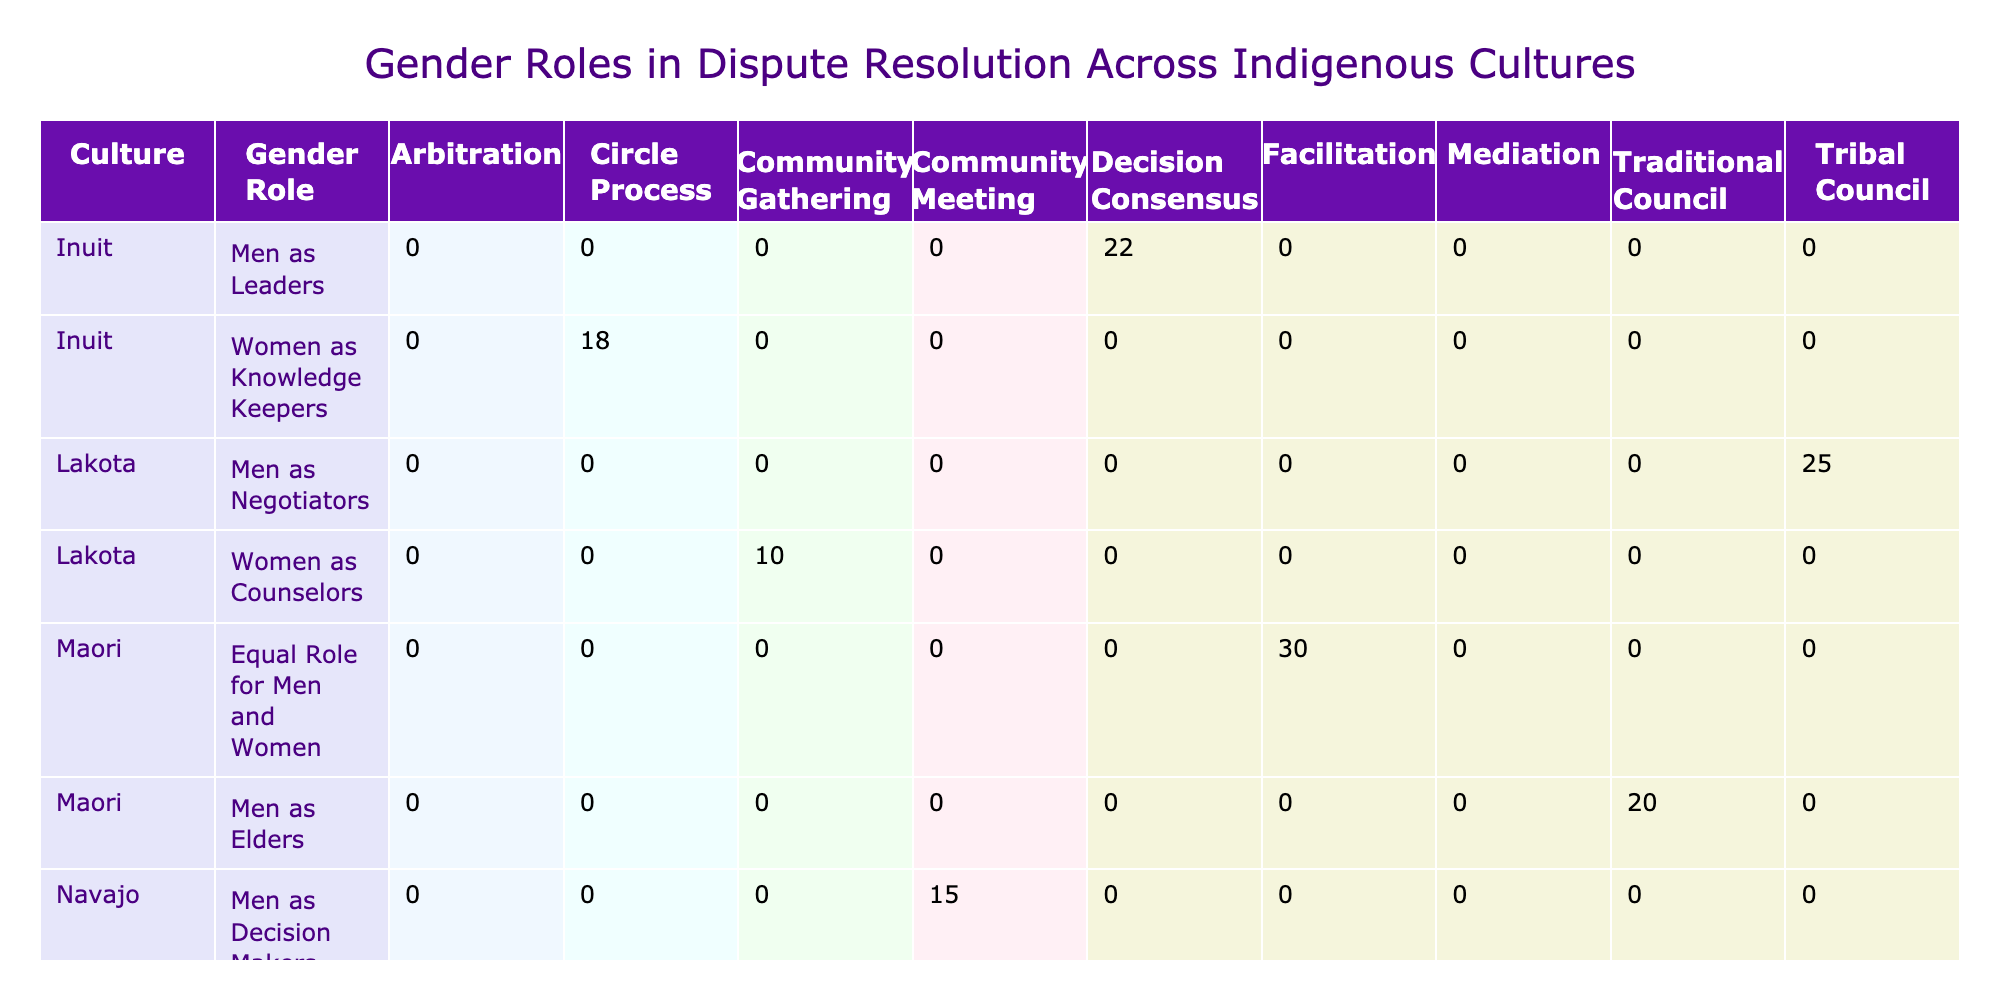What is the most common dispute resolution method among the Navajo culture? In the table, the frequencies for the Navajo culture show that "Mediation" with 25 occurrences is higher than "Community Meeting," which has 15 occurrences. Since mediation has the highest frequency, it is the most common method.
Answer: Mediation How many total frequencies are associated with the Inuit culture? The table lists the frequencies for Inuit culture as 18 for "Circle Process" and 22 for "Decision Consensus." Adding these gives 18 + 22 = 40 as the total frequency for Inuit culture.
Answer: 40 Do the Maori culture portray a clear gender division in dispute resolution roles? The Maori culture shows "Equal Role for Men and Women" and also has "Men as Elders." Since there is a role that explicitly states equality, it indicates a lack of strict gender division. Therefore, it is false to say they portray a clear gender division.
Answer: No Which culture has the least occurrences for their gender role in dispute resolution? By examining the frequency column, "Taino" has the least occurrences with "Women as Family Representatives" at 12 and "Men as Authority Figures" at 5. The total frequency for Taino is 12 + 5 = 17, which is less than any other culture listed.
Answer: Taino What is the frequency difference between "Women as Mediators" and "Men as Negotiators"? "Women as Mediators" has a frequency of 25 in the Navajo culture, whereas "Men as Negotiators" has a frequency of 25 in the Lakota culture. Since both values are equal, the difference is 25 - 25 = 0.
Answer: 0 How many cultures have "Women" in a role related to dispute resolution? The table indicates that multiple roles involving women exist: "Women as Mediators" in Navajo, "Women as Knowledge Keepers" in Inuit, and "Women as Counselors" in Lakota, totaling three distinct references.
Answer: 3 What percentage of the total dispute resolution methods in the Lakota culture involve women? The total frequency for Lakota culture is 10 (Counselors) + 25 (Negotiators) = 35. The frequency involving women is 10. So the percentage of women’s roles is (10 / 35) * 100, which is approximately 28.57%.
Answer: 28.57% Is there any culture where both genders are equally involved in dispute resolution roles? The Maori culture explicitly mentions "Equal Role for Men and Women," indicating that they have a structure where both genders are represented equally in dispute resolution. Therefore, the answer is yes.
Answer: Yes 